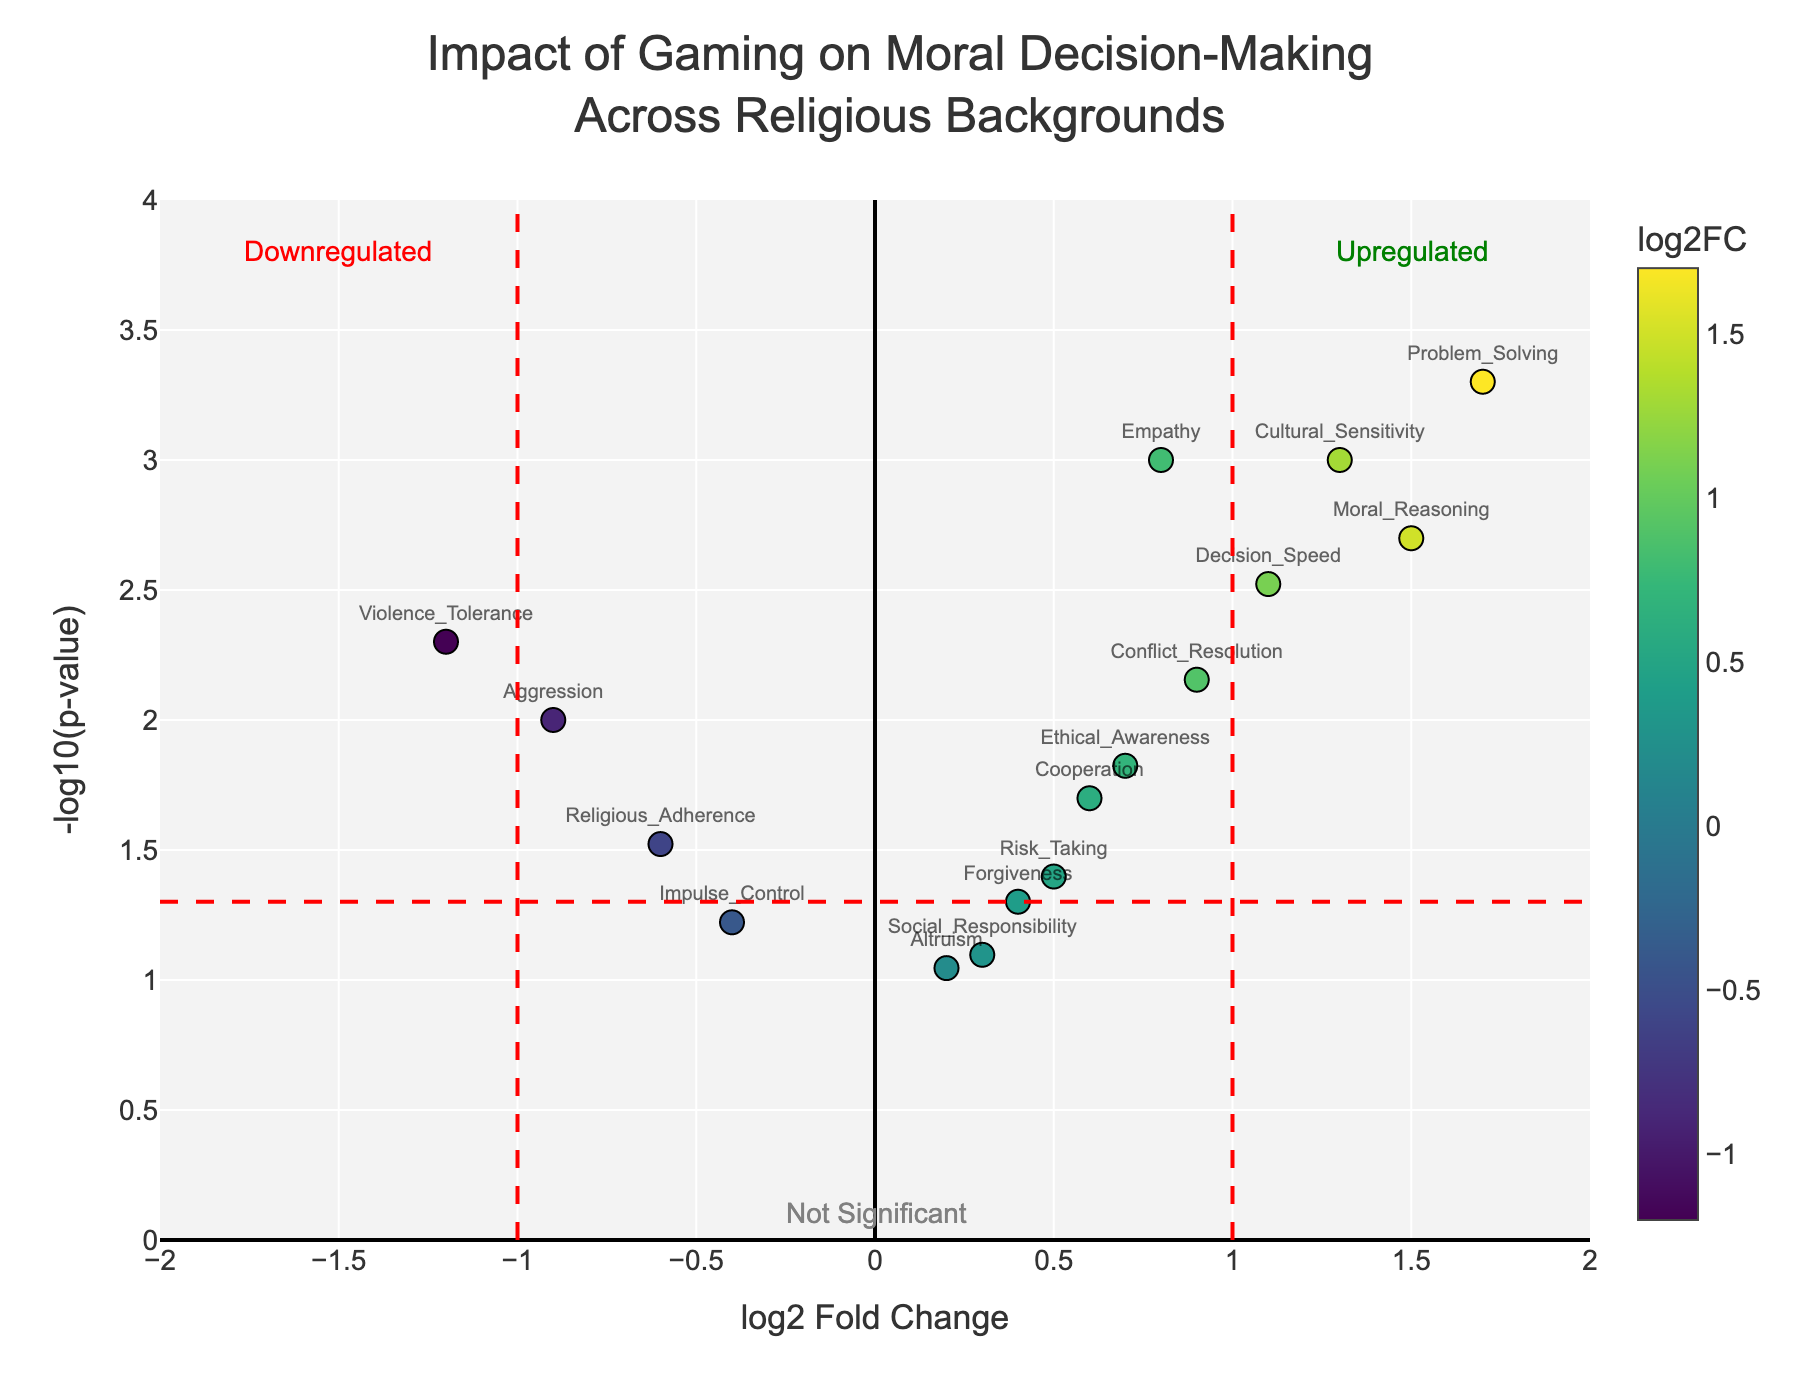How many genes have a log2 Fold Change greater than 1? To find out how many genes have a log2 Fold Change greater than 1, look for points on the plot that are positioned to the right of the vertical red dashed line at x = 1.
Answer: 5 Which gene has the highest -log10(p-value)? To determine which gene has the highest -log10(p-value), look for the highest point on the y-axis.
Answer: Problem_Solving What is the log2 Fold Change of 'Violence_Tolerance'? To determine the log2 Fold Change of 'Violence_Tolerance', locate the point labeled 'Violence_Tolerance' on the x-axis.
Answer: -1.2 How many genes are considered statistically significant with a p-value below 0.05? Genes are statistically significant if their -log10(p-value) is above the threshold (horizontal red dashed line). Count the genes above this line.
Answer: 11 Which gene reflects the most downregulation in moral decision-making? Downregulation is indicated by a negative log2 Fold Change. Identify the gene with the lowest log2 Fold Change.
Answer: Violence_Tolerance What is the range of log2 Fold Change values displayed in the plot? The range of log2 Fold Change values can be seen by looking at the x-axis boundaries of the plot.
Answer: -2 to 2 Which gene has the lowest log2 Fold Change but is still statistically significant? To find the gene with the lowest log2 Fold Change that is statistically significant, identify the leftmost gene that is above the horizontal red dashed line.
Answer: Violence_Tolerance How many genes have a positive log2 Fold Change but are not statistically significant? Positive log2 Fold Change values are to the right of x=0, and genes not statistically significant are below the horizontal red dashed line. Count these points.
Answer: 3 Compare the log2 Fold Change of 'Empathy' with that of 'Aggression'. Which one is higher? Locate the points labeled 'Empathy' and 'Aggression' on the plot. Compare their positions on the x-axis.
Answer: Empathy What is the significance p-value threshold represented by the red dashed horizontal line? The red dashed horizontal line represents the significance threshold, which is -log10(0.05). Calculate this value.
Answer: 1.3010 